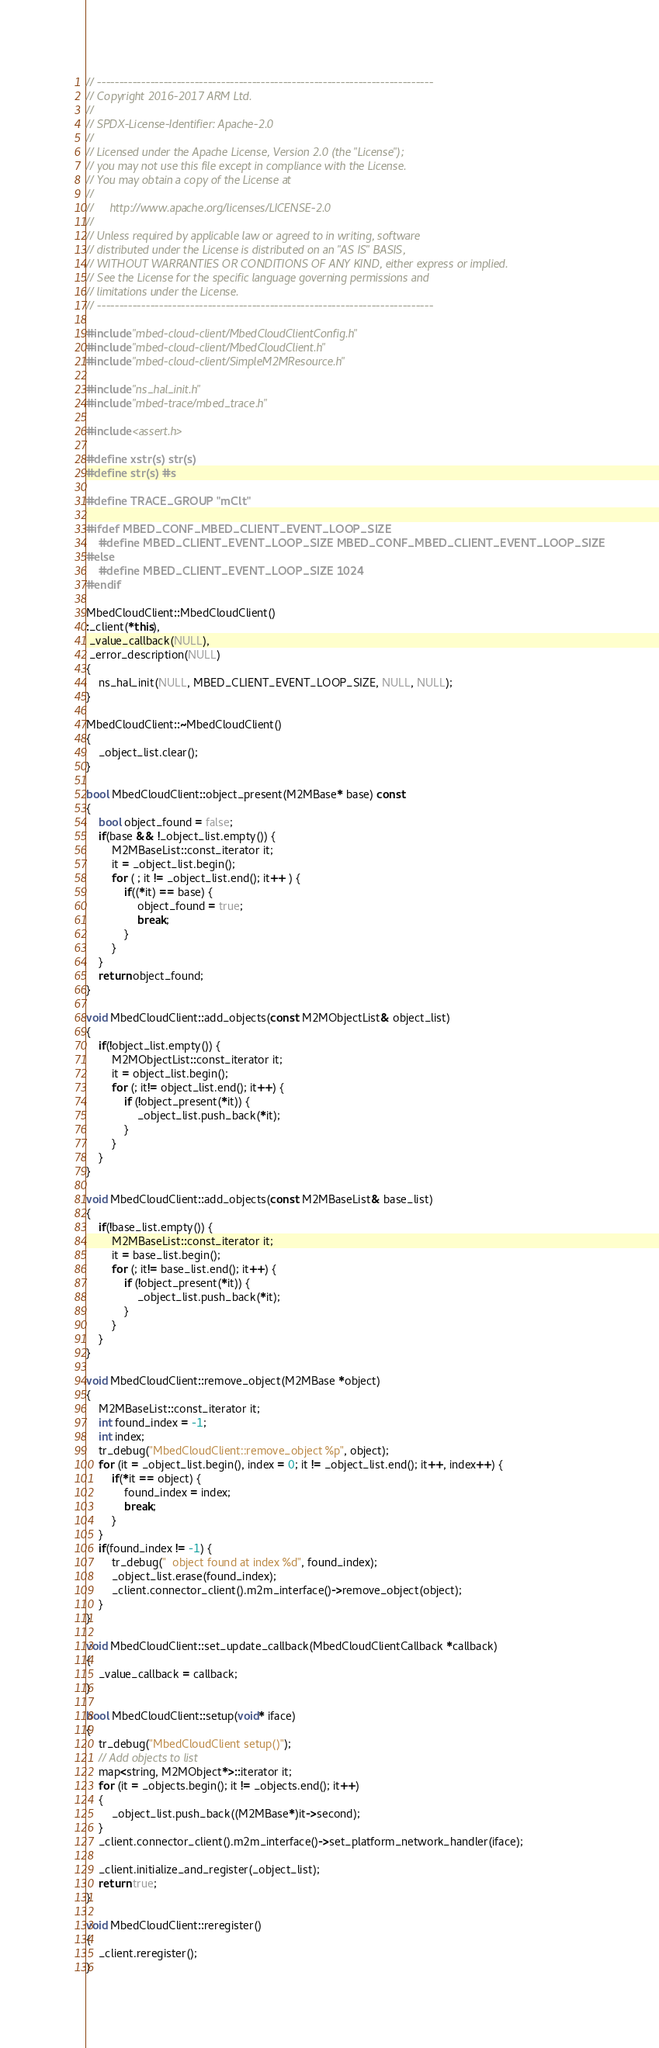<code> <loc_0><loc_0><loc_500><loc_500><_C++_>// ----------------------------------------------------------------------------
// Copyright 2016-2017 ARM Ltd.
//
// SPDX-License-Identifier: Apache-2.0
//
// Licensed under the Apache License, Version 2.0 (the "License");
// you may not use this file except in compliance with the License.
// You may obtain a copy of the License at
//
//     http://www.apache.org/licenses/LICENSE-2.0
//
// Unless required by applicable law or agreed to in writing, software
// distributed under the License is distributed on an "AS IS" BASIS,
// WITHOUT WARRANTIES OR CONDITIONS OF ANY KIND, either express or implied.
// See the License for the specific language governing permissions and
// limitations under the License.
// ----------------------------------------------------------------------------

#include "mbed-cloud-client/MbedCloudClientConfig.h"
#include "mbed-cloud-client/MbedCloudClient.h"
#include "mbed-cloud-client/SimpleM2MResource.h"

#include "ns_hal_init.h"
#include "mbed-trace/mbed_trace.h"

#include <assert.h>

#define xstr(s) str(s)
#define str(s) #s

#define TRACE_GROUP "mClt"

#ifdef MBED_CONF_MBED_CLIENT_EVENT_LOOP_SIZE
    #define MBED_CLIENT_EVENT_LOOP_SIZE MBED_CONF_MBED_CLIENT_EVENT_LOOP_SIZE
#else
    #define MBED_CLIENT_EVENT_LOOP_SIZE 1024
#endif

MbedCloudClient::MbedCloudClient()
:_client(*this),
 _value_callback(NULL),
 _error_description(NULL)
{
    ns_hal_init(NULL, MBED_CLIENT_EVENT_LOOP_SIZE, NULL, NULL);
}

MbedCloudClient::~MbedCloudClient()
{
    _object_list.clear();
}

bool MbedCloudClient::object_present(M2MBase* base) const
{
    bool object_found = false;
    if(base && !_object_list.empty()) {
        M2MBaseList::const_iterator it;
        it = _object_list.begin();
        for ( ; it != _object_list.end(); it++ ) {
            if((*it) == base) {
            	object_found = true;
                break;
            }
        }
    }
    return object_found;
}

void MbedCloudClient::add_objects(const M2MObjectList& object_list)
{
    if(!object_list.empty()) {
        M2MObjectList::const_iterator it;
        it = object_list.begin();
        for (; it!= object_list.end(); it++) {
            if (!object_present(*it)) {
                _object_list.push_back(*it);
            }
        }
    }
}

void MbedCloudClient::add_objects(const M2MBaseList& base_list)
{
    if(!base_list.empty()) {
        M2MBaseList::const_iterator it;
        it = base_list.begin();
        for (; it!= base_list.end(); it++) {
            if (!object_present(*it)) {
                _object_list.push_back(*it);
            }
        }
    }
}

void MbedCloudClient::remove_object(M2MBase *object)
{
    M2MBaseList::const_iterator it;
    int found_index = -1;
    int index;
    tr_debug("MbedCloudClient::remove_object %p", object);
    for (it = _object_list.begin(), index = 0; it != _object_list.end(); it++, index++) {
        if(*it == object) {
            found_index = index;
            break;
        }
    }
    if(found_index != -1) {
        tr_debug("  object found at index %d", found_index);
        _object_list.erase(found_index);
        _client.connector_client().m2m_interface()->remove_object(object);
    }
}

void MbedCloudClient::set_update_callback(MbedCloudClientCallback *callback)
{
    _value_callback = callback;
}

bool MbedCloudClient::setup(void* iface)
{
    tr_debug("MbedCloudClient setup()");
    // Add objects to list
    map<string, M2MObject*>::iterator it;
    for (it = _objects.begin(); it != _objects.end(); it++)
    {
        _object_list.push_back((M2MBase*)it->second);
    }
    _client.connector_client().m2m_interface()->set_platform_network_handler(iface);

    _client.initialize_and_register(_object_list);
    return true;
}

void MbedCloudClient::reregister()
{
    _client.reregister();
}

</code> 